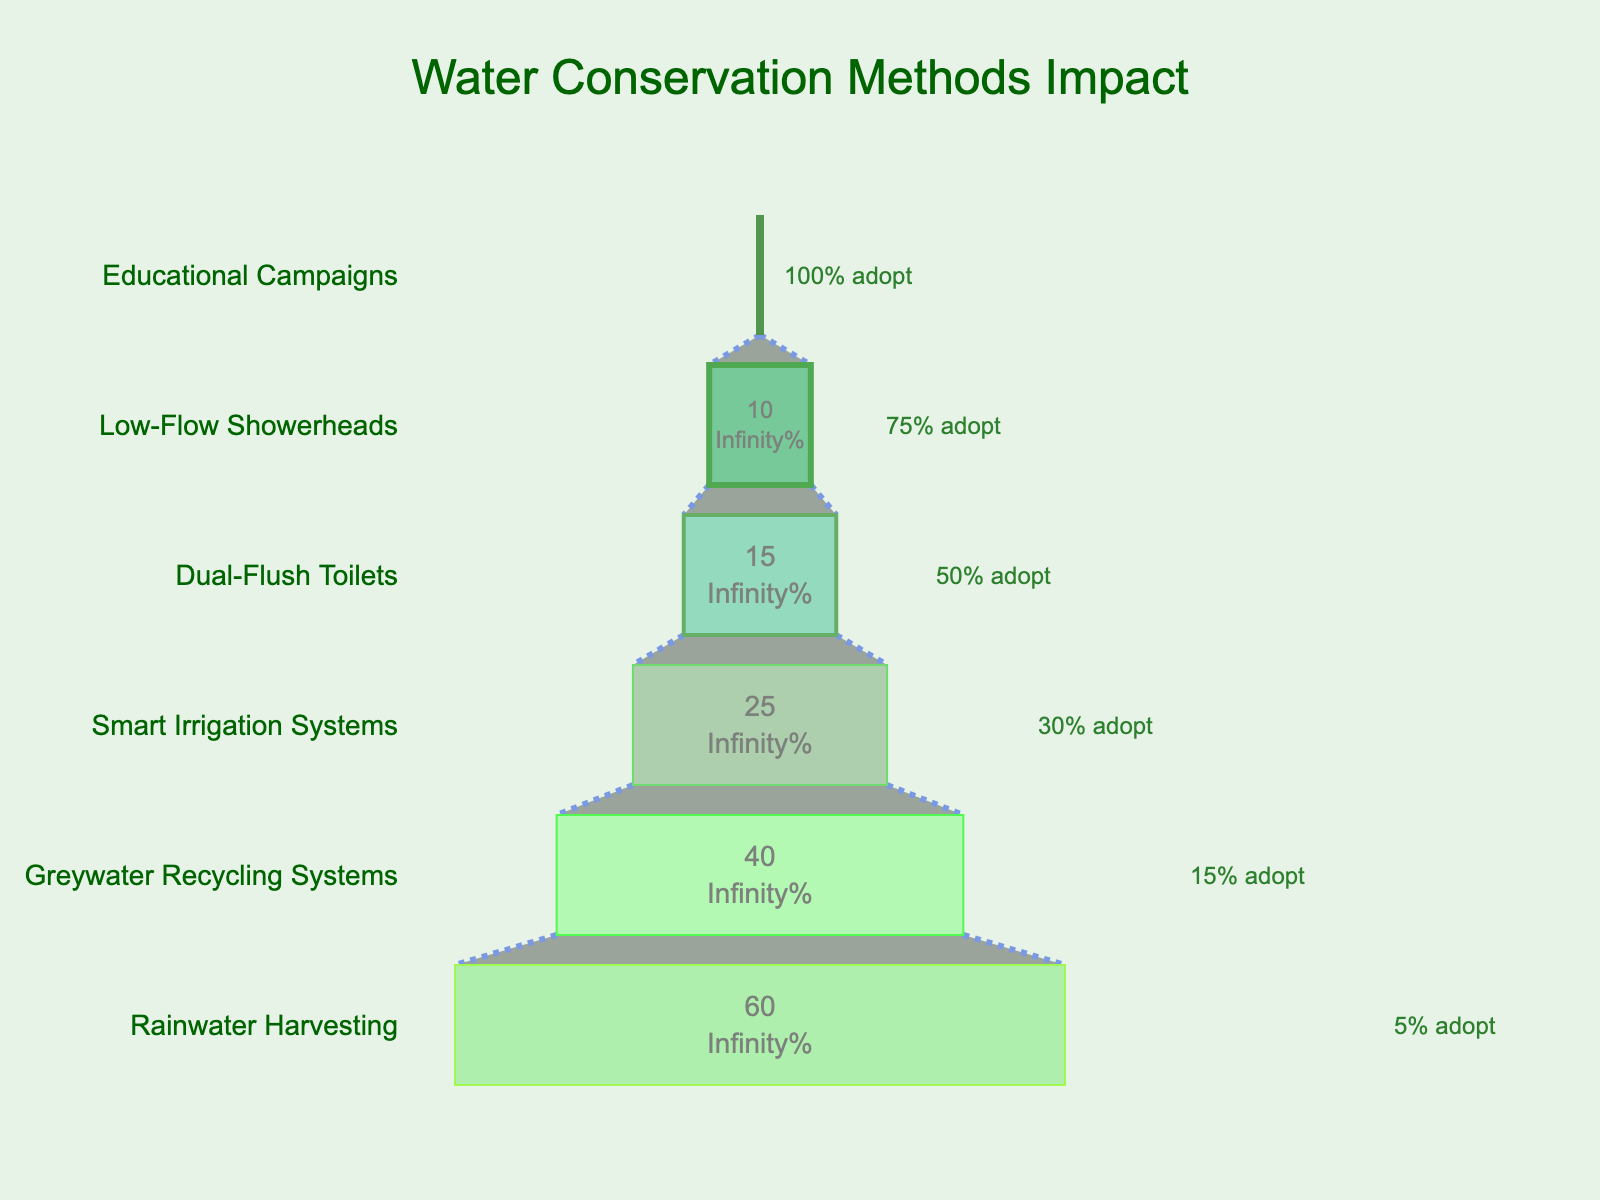What's the title of the funnel chart? The title is typically at the top center of the chart. In this funnel chart, the title is "Water Conservation Methods Impact" as indicated by the text and its position in the figure.
Answer: Water Conservation Methods Impact How many methods of water conservation are displayed in the chart? To find this, count the number of different water conservation methods listed vertically along the y-axis.
Answer: 6 Which water conservation method results in the highest average water savings? Look for the bar that reaches the furthest to the right because it represents the largest average water savings.
Answer: Rainwater Harvesting What percentage of households adopt low-flow showerheads? This can be found by looking at the annotation next to the low-flow showerheads bar. The annotation indicates the adoption rate.
Answer: 75% Compare the average water savings between the dual-flush toilets and smart irrigation systems. Which method saves more water? Check the lengths of the bars for dual-flush toilets and smart irrigation systems, and compare their rightmost endpoints. The longer bar represents the method with higher average water savings.
Answer: Smart Irrigation Systems How much more water does the rainwater harvesting method save compared to the greywater recycling systems per day? Find the bar lengths for both methods and then subtract the average water savings of greywater recycling systems from that of rainwater harvesting.
Answer: 20 gallons/day Which method has the lowest percentage of household adoption? Look for the method with the smallest adoption rate annotation, typically the bar at the bottom of the funnel.
Answer: Rainwater Harvesting What is the combined household adoption percentage for dual-flush toilets and smart irrigation systems? Add the household adoption percentages of dual-flush toilets (50%) and smart irrigation systems (30%).
Answer: 80% Calculate the average water savings for basic and intermediate methods. Sum the average water savings of low-flow showerheads (10 gallons/day) and dual-flush toilets (15 gallons/day), then divide by 2.
Answer: 12.5 gallons/day Describe how the chart visually communicates the change in water savings across different methods. The funnel chart uses progressively larger bars to the right to indicate increasing average water savings with each method, while annotations show the percentage of household adoption.
Answer: Increasing water savings and varying household adoption percentages 